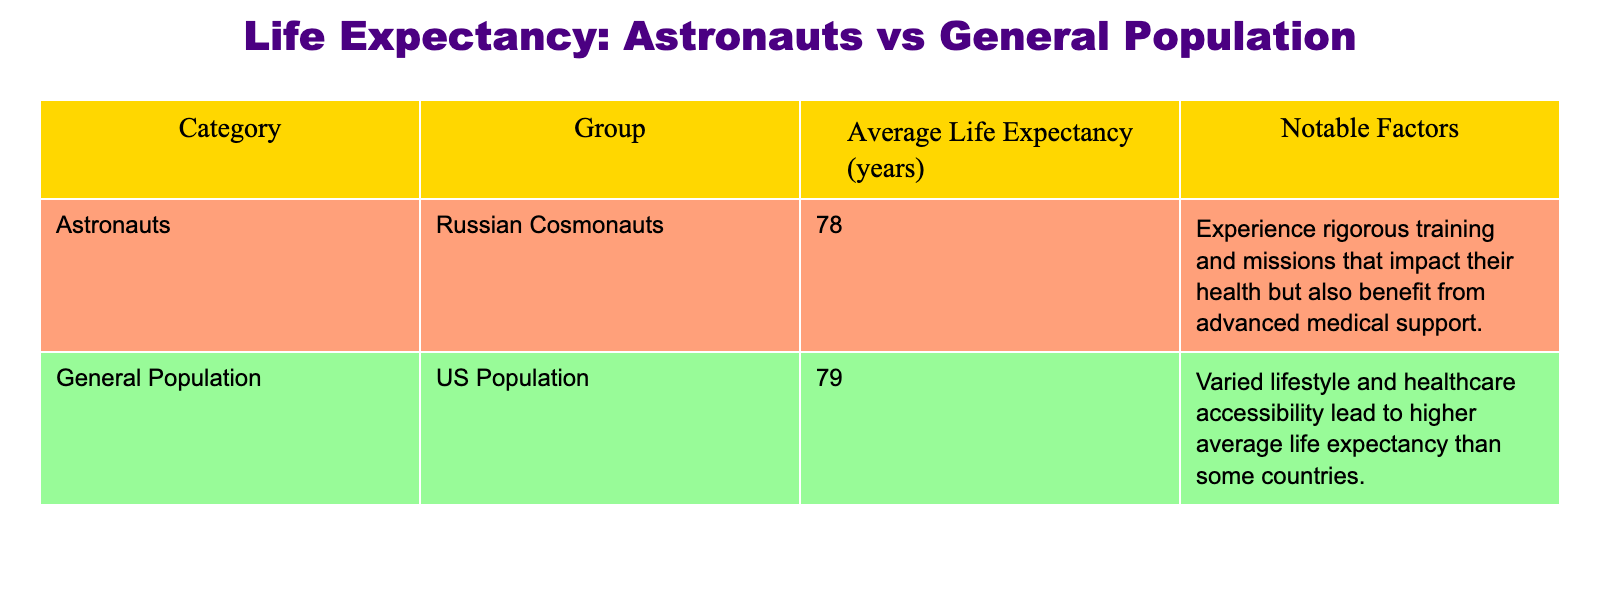What is the average life expectancy of Russian cosmonauts? The table lists the average life expectancy of Russian cosmonauts as 78 years.
Answer: 78 What is the average life expectancy of the US population? The table indicates that the average life expectancy of the US population is 79 years.
Answer: 79 Which group has a higher average life expectancy? The average life expectancy of the US population (79 years) is higher than that of Russian cosmonauts (78 years).
Answer: US population What notable factor could explain the life expectancy of Russian cosmonauts? The table mentions that Russian cosmonauts experience rigorous training and missions that impact their health but benefit from advanced medical support, which can contribute to their life expectancy.
Answer: Advanced medical support Is the average life expectancy of the general population higher than that of astronauts? Yes, the average life expectancy of the US population (79 years) is higher than that of Russian cosmonauts (78 years).
Answer: Yes What is the difference in average life expectancy between the two groups? The average life expectancy of the US population (79 years) minus the average life expectancy of Russian cosmonauts (78 years) results in a difference of 1 year.
Answer: 1 year Based on the table, do astronauts have a longer life expectancy than the general population? No, astronauts (Russian cosmonauts) have a shorter average life expectancy (78 years) than the general population (79 years).
Answer: No Considering the data, which notable factors are mentioned for the US population's life expectancy? The table states that varied lifestyle and healthcare accessibility lead to higher average life expectancy for the US population compared to some countries, highlighting the importance of these factors.
Answer: Varied lifestyle and healthcare access If we were to average the life expectancies of both groups, what would that value be? To find the average, we take the sum of the average life expectancies (78 + 79) and divide by 2. The calculation is (157 / 2) which equals 78.5 years.
Answer: 78.5 years Does the data suggest that training and medical support improve astronauts' life expectancy? While the table notes that Russian cosmonauts benefit from advanced medical support, it does not definitively state that this improves their life expectancy compared to the general population. Therefore, the answer is not explicitly supported by the table data.
Answer: Not explicitly stated 